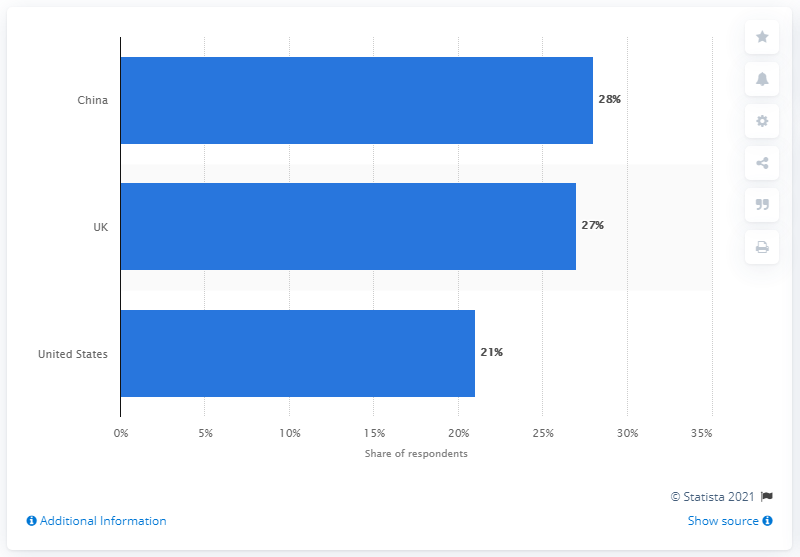Specify some key components in this picture. Recent cross-border orders from Iceland accounted for 30% of which a significant portion came from China. The most recent purchases made by Icelanders were made in the United States. 